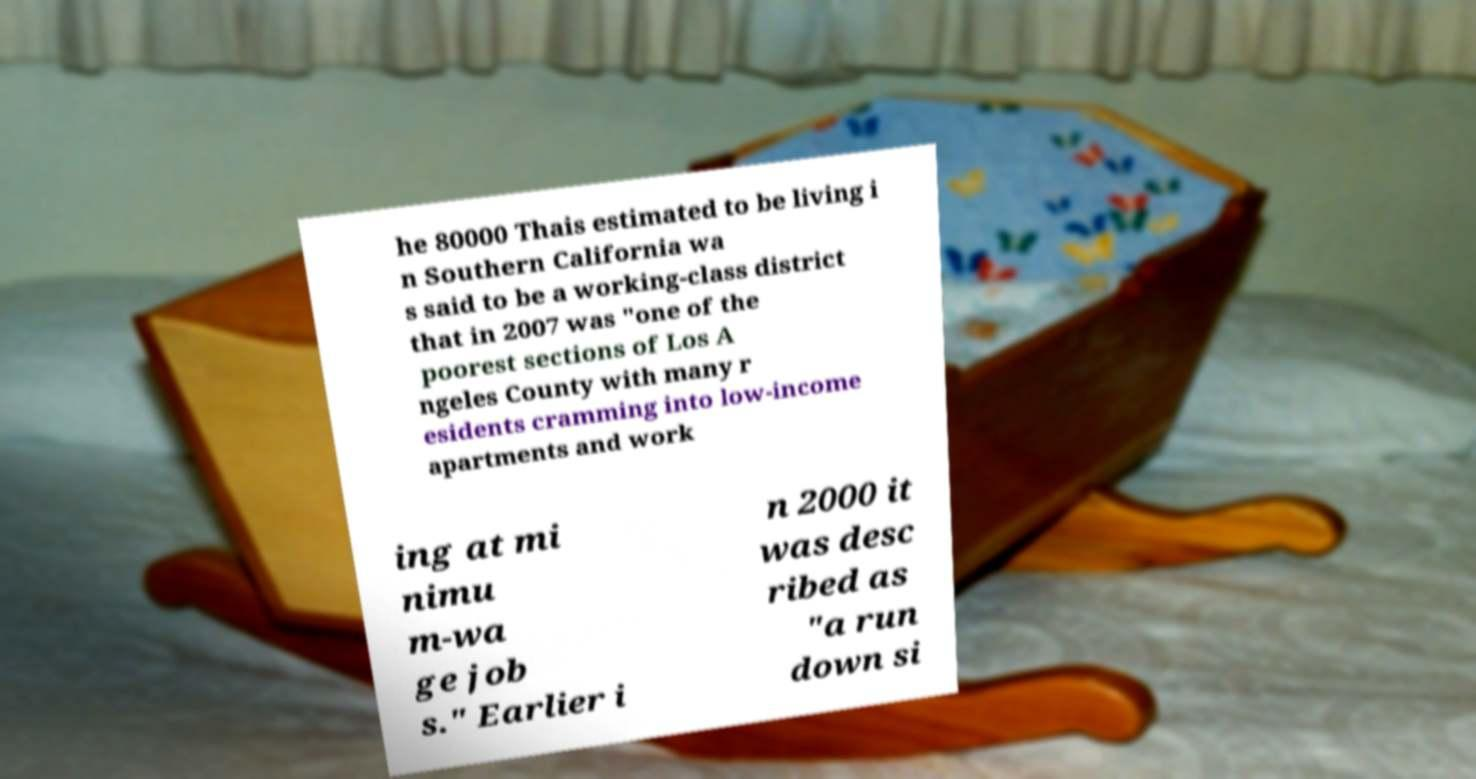Could you assist in decoding the text presented in this image and type it out clearly? he 80000 Thais estimated to be living i n Southern California wa s said to be a working-class district that in 2007 was "one of the poorest sections of Los A ngeles County with many r esidents cramming into low-income apartments and work ing at mi nimu m-wa ge job s." Earlier i n 2000 it was desc ribed as "a run down si 